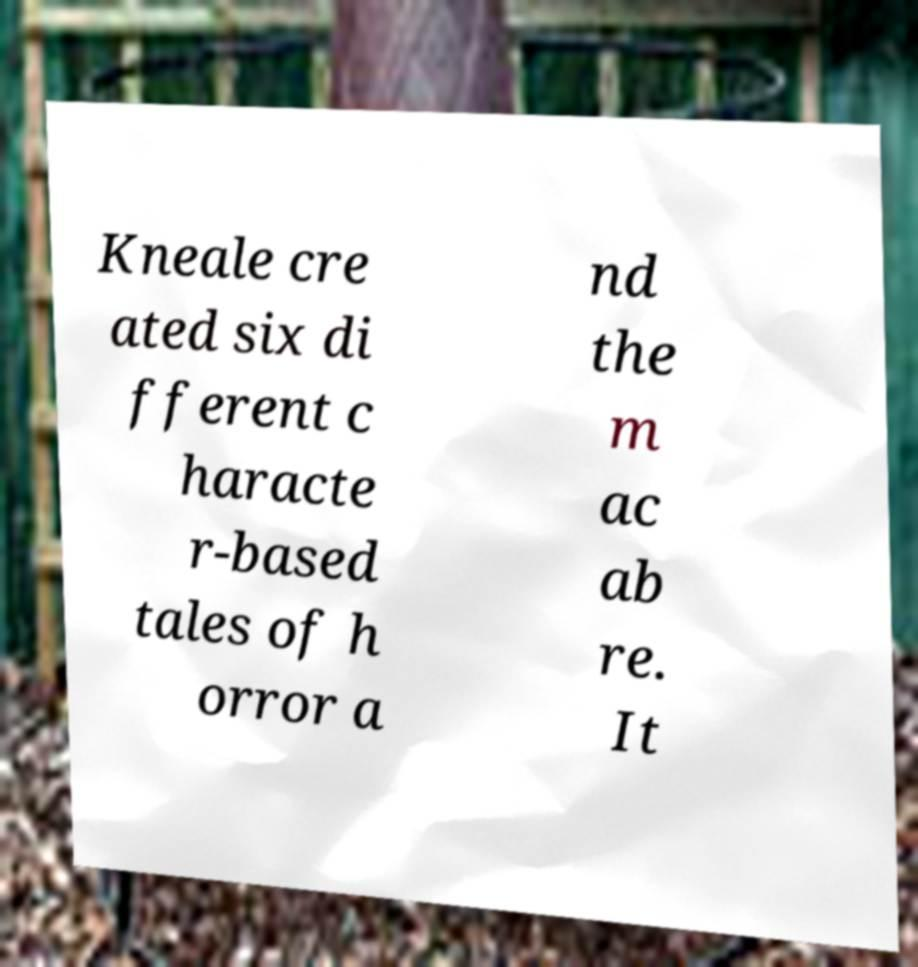Can you accurately transcribe the text from the provided image for me? Kneale cre ated six di fferent c haracte r-based tales of h orror a nd the m ac ab re. It 